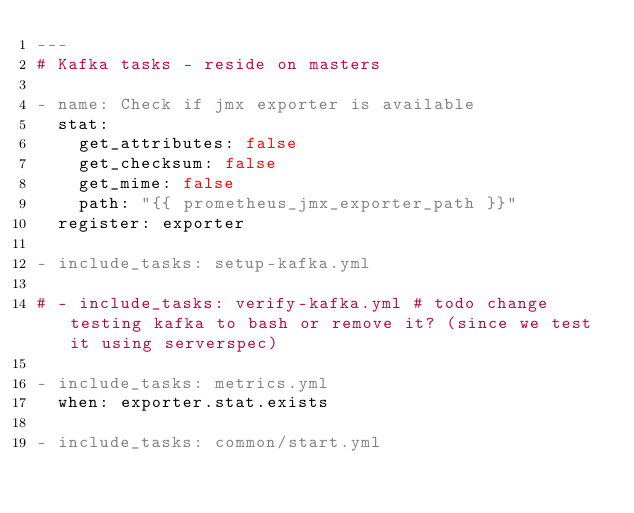Convert code to text. <code><loc_0><loc_0><loc_500><loc_500><_YAML_>---
# Kafka tasks - reside on masters

- name: Check if jmx exporter is available
  stat:
    get_attributes: false
    get_checksum: false
    get_mime: false
    path: "{{ prometheus_jmx_exporter_path }}"
  register: exporter

- include_tasks: setup-kafka.yml

# - include_tasks: verify-kafka.yml # todo change testing kafka to bash or remove it? (since we test it using serverspec)

- include_tasks: metrics.yml
  when: exporter.stat.exists

- include_tasks: common/start.yml
</code> 